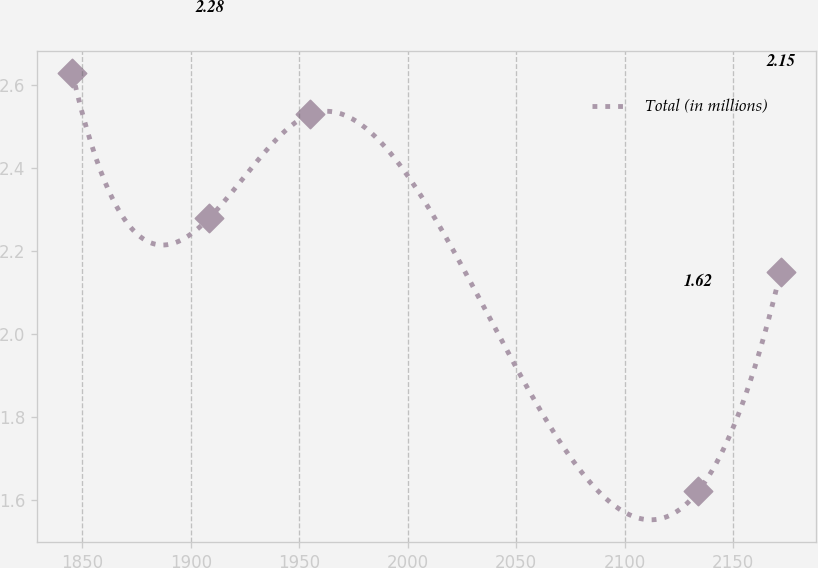<chart> <loc_0><loc_0><loc_500><loc_500><line_chart><ecel><fcel>Total (in millions)<nl><fcel>1845.39<fcel>2.63<nl><fcel>1908.54<fcel>2.28<nl><fcel>1954.99<fcel>2.53<nl><fcel>2133.74<fcel>1.62<nl><fcel>2171.82<fcel>2.15<nl></chart> 